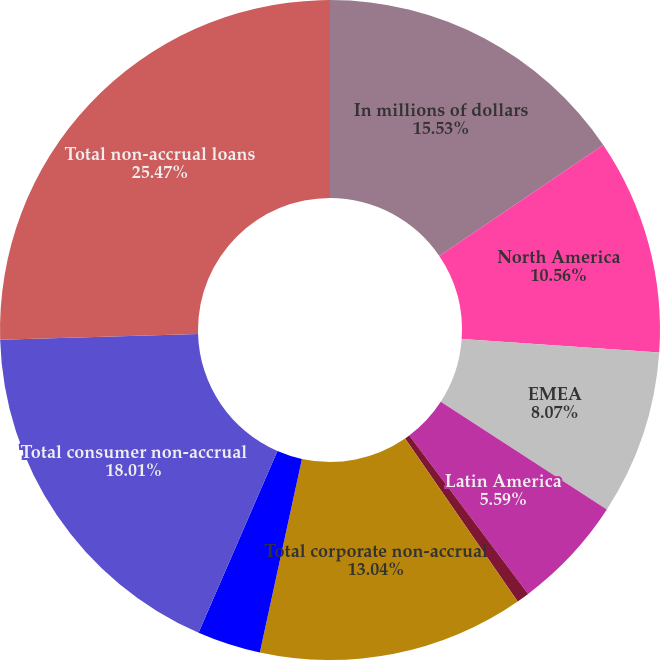<chart> <loc_0><loc_0><loc_500><loc_500><pie_chart><fcel>In millions of dollars<fcel>North America<fcel>EMEA<fcel>Latin America<fcel>Asia<fcel>Total corporate non-accrual<fcel>Asia (4)<fcel>Total consumer non-accrual<fcel>Total non-accrual loans<nl><fcel>15.53%<fcel>10.56%<fcel>8.07%<fcel>5.59%<fcel>0.62%<fcel>13.04%<fcel>3.11%<fcel>18.01%<fcel>25.47%<nl></chart> 